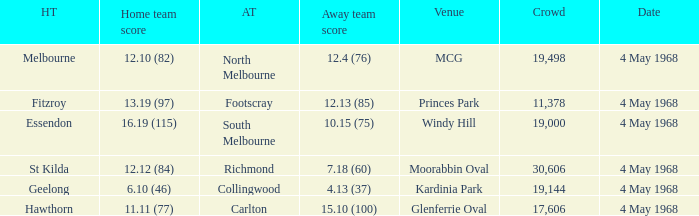What away team played at Kardinia Park? 4.13 (37). 